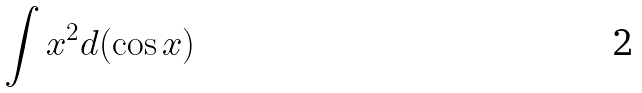Convert formula to latex. <formula><loc_0><loc_0><loc_500><loc_500>\int x ^ { 2 } d ( \cos x )</formula> 